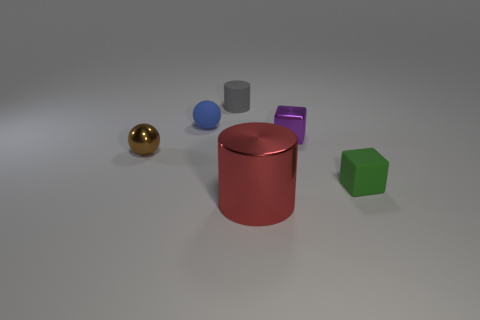Is the number of brown balls greater than the number of big rubber things?
Offer a terse response. Yes. What is the size of the red thing?
Provide a succinct answer. Large. Is the material of the cylinder behind the small green rubber object the same as the purple block?
Offer a terse response. No. Are there fewer tiny spheres that are right of the tiny matte cube than gray cylinders that are on the right side of the gray matte cylinder?
Make the answer very short. No. What number of other things are the same material as the brown sphere?
Provide a succinct answer. 2. What is the material of the other green cube that is the same size as the shiny cube?
Give a very brief answer. Rubber. Are there fewer matte cylinders that are on the right side of the small green matte cube than tiny blocks?
Your answer should be very brief. Yes. There is a tiny shiny thing that is left of the tiny blue sphere on the right side of the shiny thing on the left side of the small matte ball; what shape is it?
Offer a terse response. Sphere. There is a ball behind the small brown sphere; what is its size?
Give a very brief answer. Small. There is a green object that is the same size as the blue rubber thing; what shape is it?
Your answer should be very brief. Cube. 